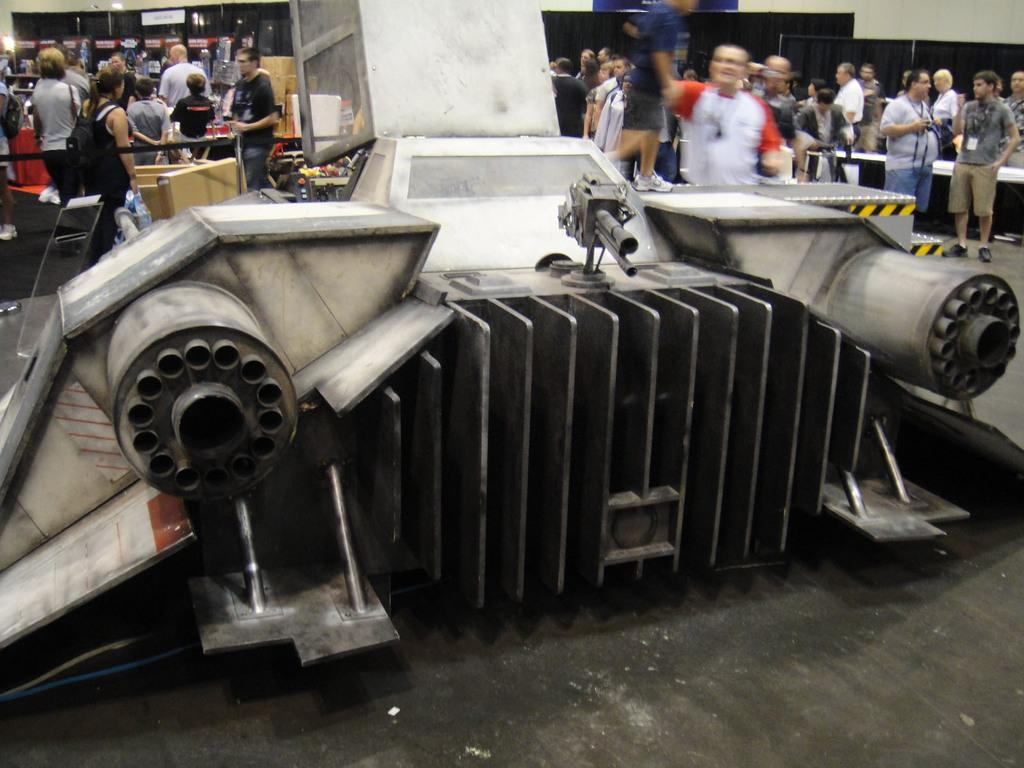What is the main subject of the image? There is an object in the image, but we cannot determine its exact nature from the given facts. What can be seen at the bottom of the image? The floor is visible at the bottom of the image. What is visible in the background of the image? In the background of the image, there are people, a wall, clothes, banners, and other objects. What is the argument about between the people in the image? There is no argument present in the image; it only shows people in the background along with other objects and elements. What is the profit margin of the parcel in the image? There is no parcel present in the image, so it is not possible to determine its profit margin. 